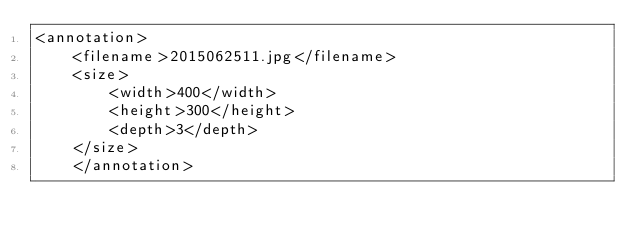<code> <loc_0><loc_0><loc_500><loc_500><_XML_><annotation>
	<filename>2015062511.jpg</filename>
	<size>
		<width>400</width>
		<height>300</height>
		<depth>3</depth>
	</size>
	</annotation></code> 